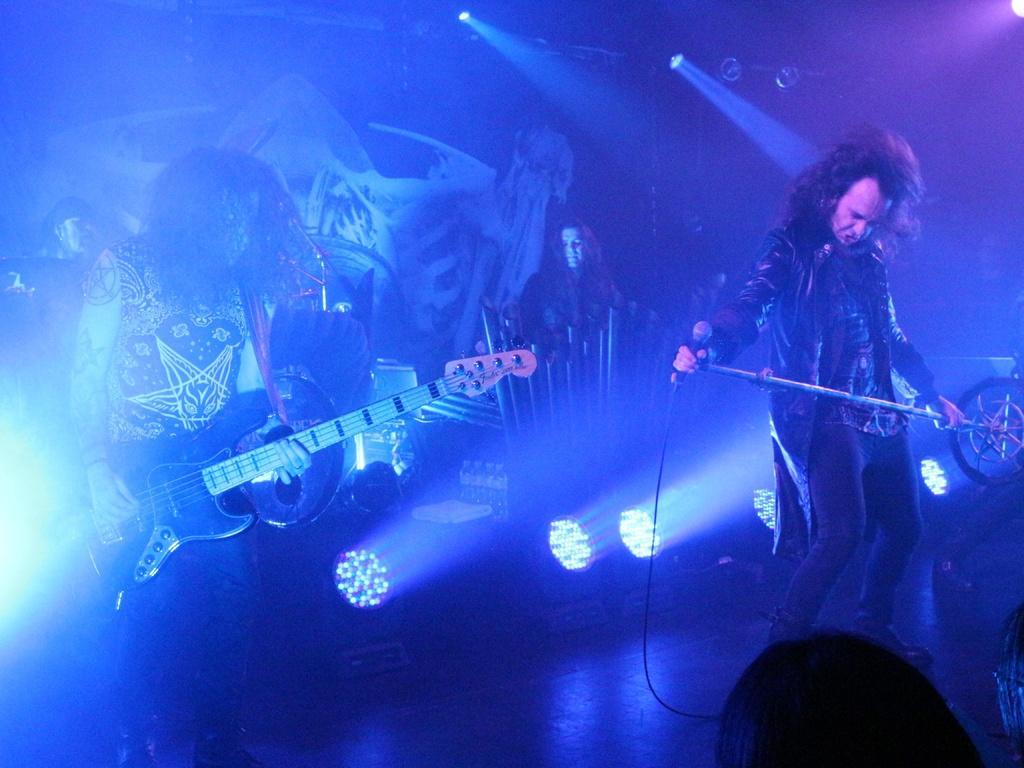Can you describe this image briefly? Four persons are present on the stage. One person is playing guitar one person is holding microphone two persons are standing. Behind them there is a poster and there are lights present on the stage. 